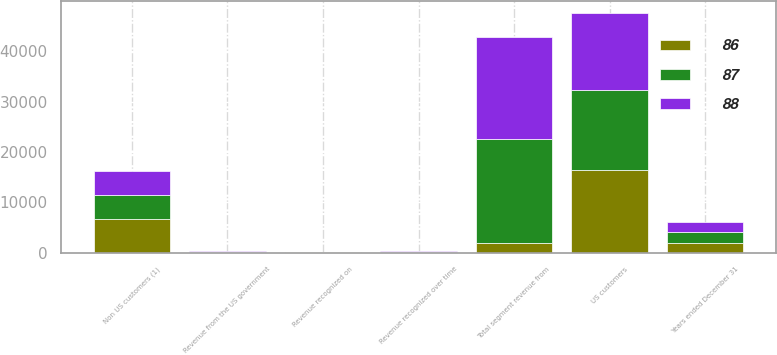Convert chart to OTSL. <chart><loc_0><loc_0><loc_500><loc_500><stacked_bar_chart><ecel><fcel>Years ended December 31<fcel>US customers<fcel>Non US customers (1)<fcel>Total segment revenue from<fcel>Revenue recognized over time<fcel>Revenue recognized on<fcel>Revenue from the US government<nl><fcel>86<fcel>2018<fcel>16492<fcel>6703<fcel>2016.5<fcel>98<fcel>65<fcel>86<nl><fcel>87<fcel>2017<fcel>15889<fcel>4672<fcel>20561<fcel>97<fcel>63<fcel>87<nl><fcel>88<fcel>2016<fcel>15227<fcel>4953<fcel>20180<fcel>99<fcel>64<fcel>88<nl></chart> 